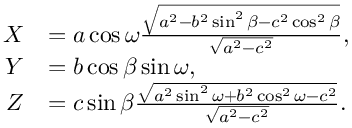<formula> <loc_0><loc_0><loc_500><loc_500>{ \begin{array} { r l } { X } & { = a \cos \omega { \frac { \sqrt { a ^ { 2 } - b ^ { 2 } \sin ^ { 2 } \beta - c ^ { 2 } \cos ^ { 2 } \beta } } { \sqrt { a ^ { 2 } - c ^ { 2 } } } } , } \\ { Y } & { = b \cos \beta \sin \omega , } \\ { Z } & { = c \sin \beta { \frac { \sqrt { a ^ { 2 } \sin ^ { 2 } \omega + b ^ { 2 } \cos ^ { 2 } \omega - c ^ { 2 } } } { \sqrt { a ^ { 2 } - c ^ { 2 } } } } . } \end{array} }</formula> 